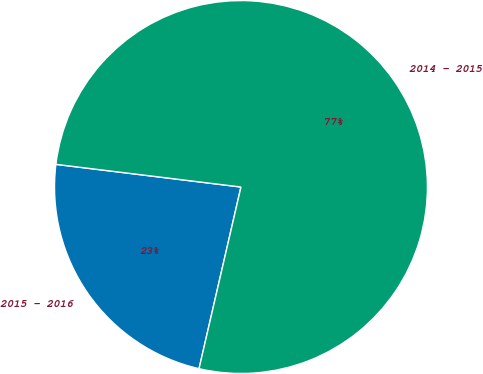<chart> <loc_0><loc_0><loc_500><loc_500><pie_chart><fcel>2015 - 2016<fcel>2014 - 2015<nl><fcel>23.33%<fcel>76.67%<nl></chart> 